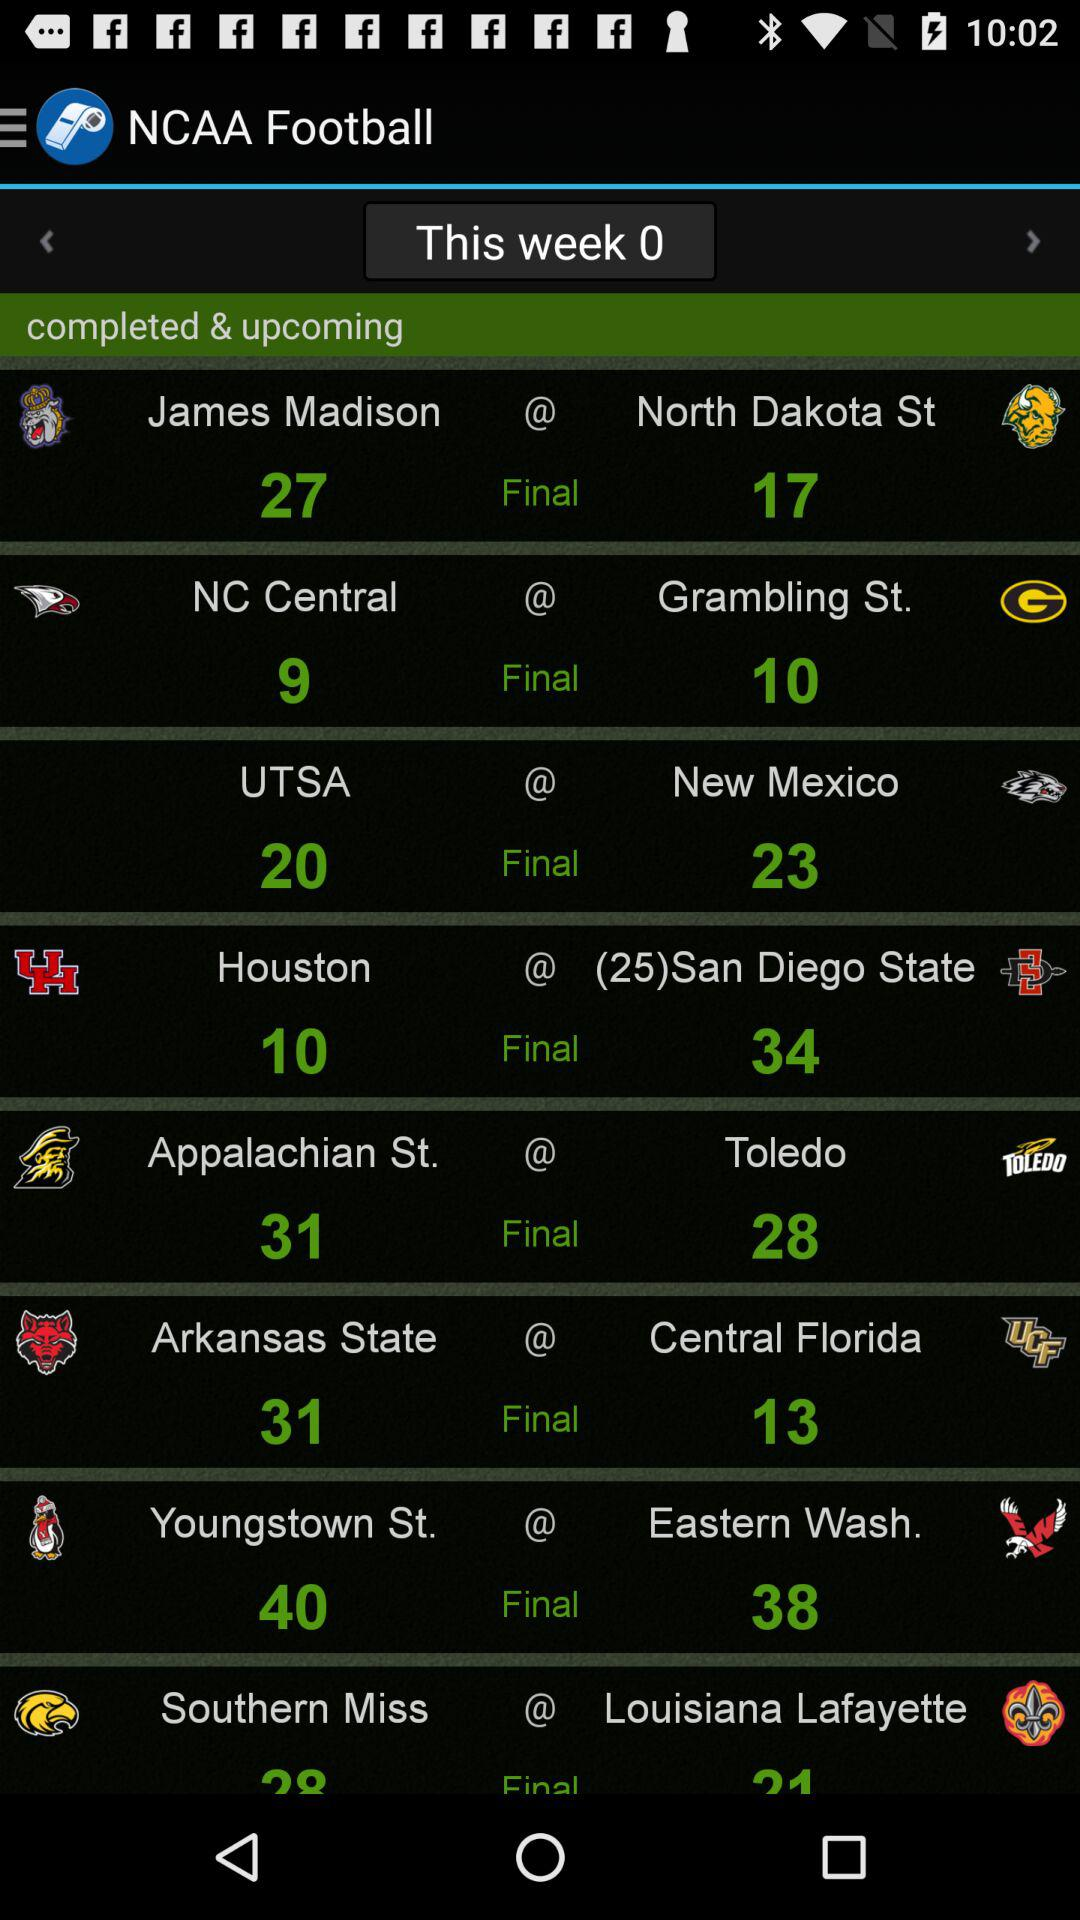What is the application name? The application name is "NCAA Football". 